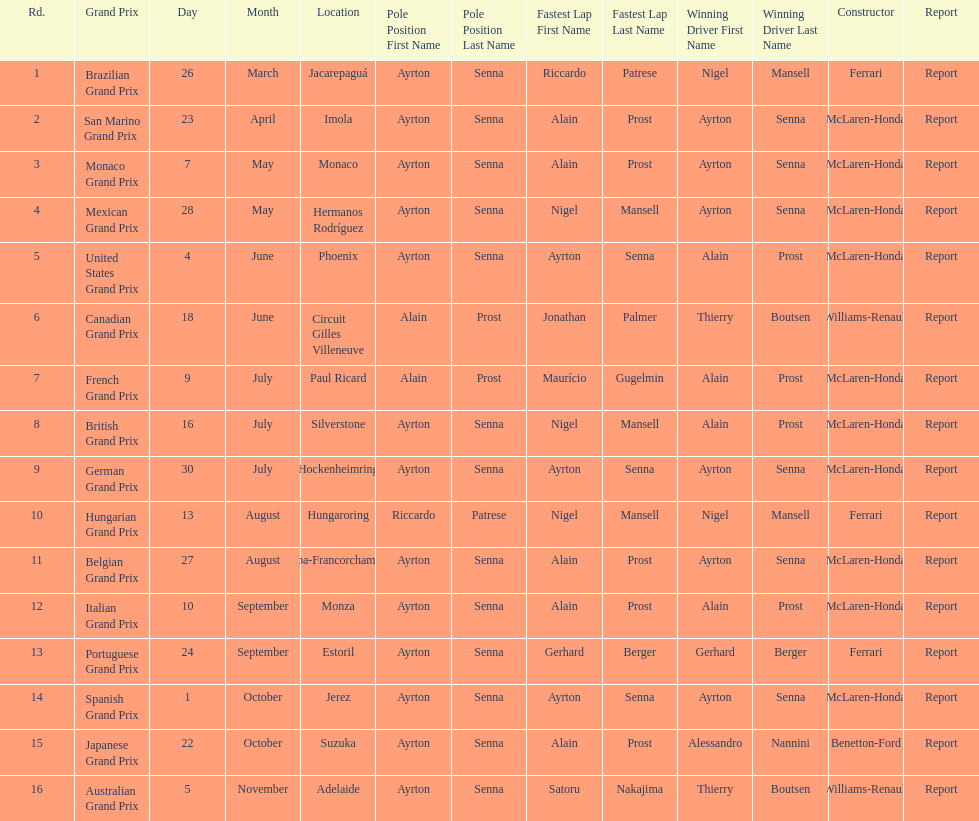How many did alain prost have the fastest lap? 5. 